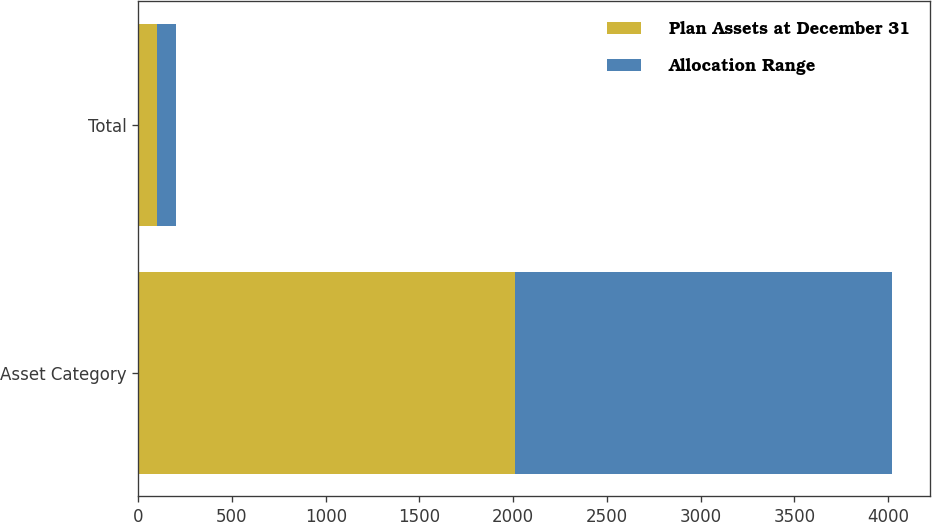Convert chart. <chart><loc_0><loc_0><loc_500><loc_500><stacked_bar_chart><ecel><fcel>Asset Category<fcel>Total<nl><fcel>Plan Assets at December 31<fcel>2012<fcel>100<nl><fcel>Allocation Range<fcel>2011<fcel>100<nl></chart> 